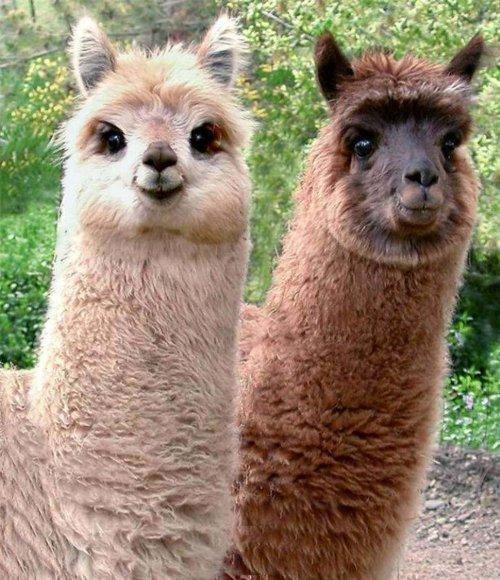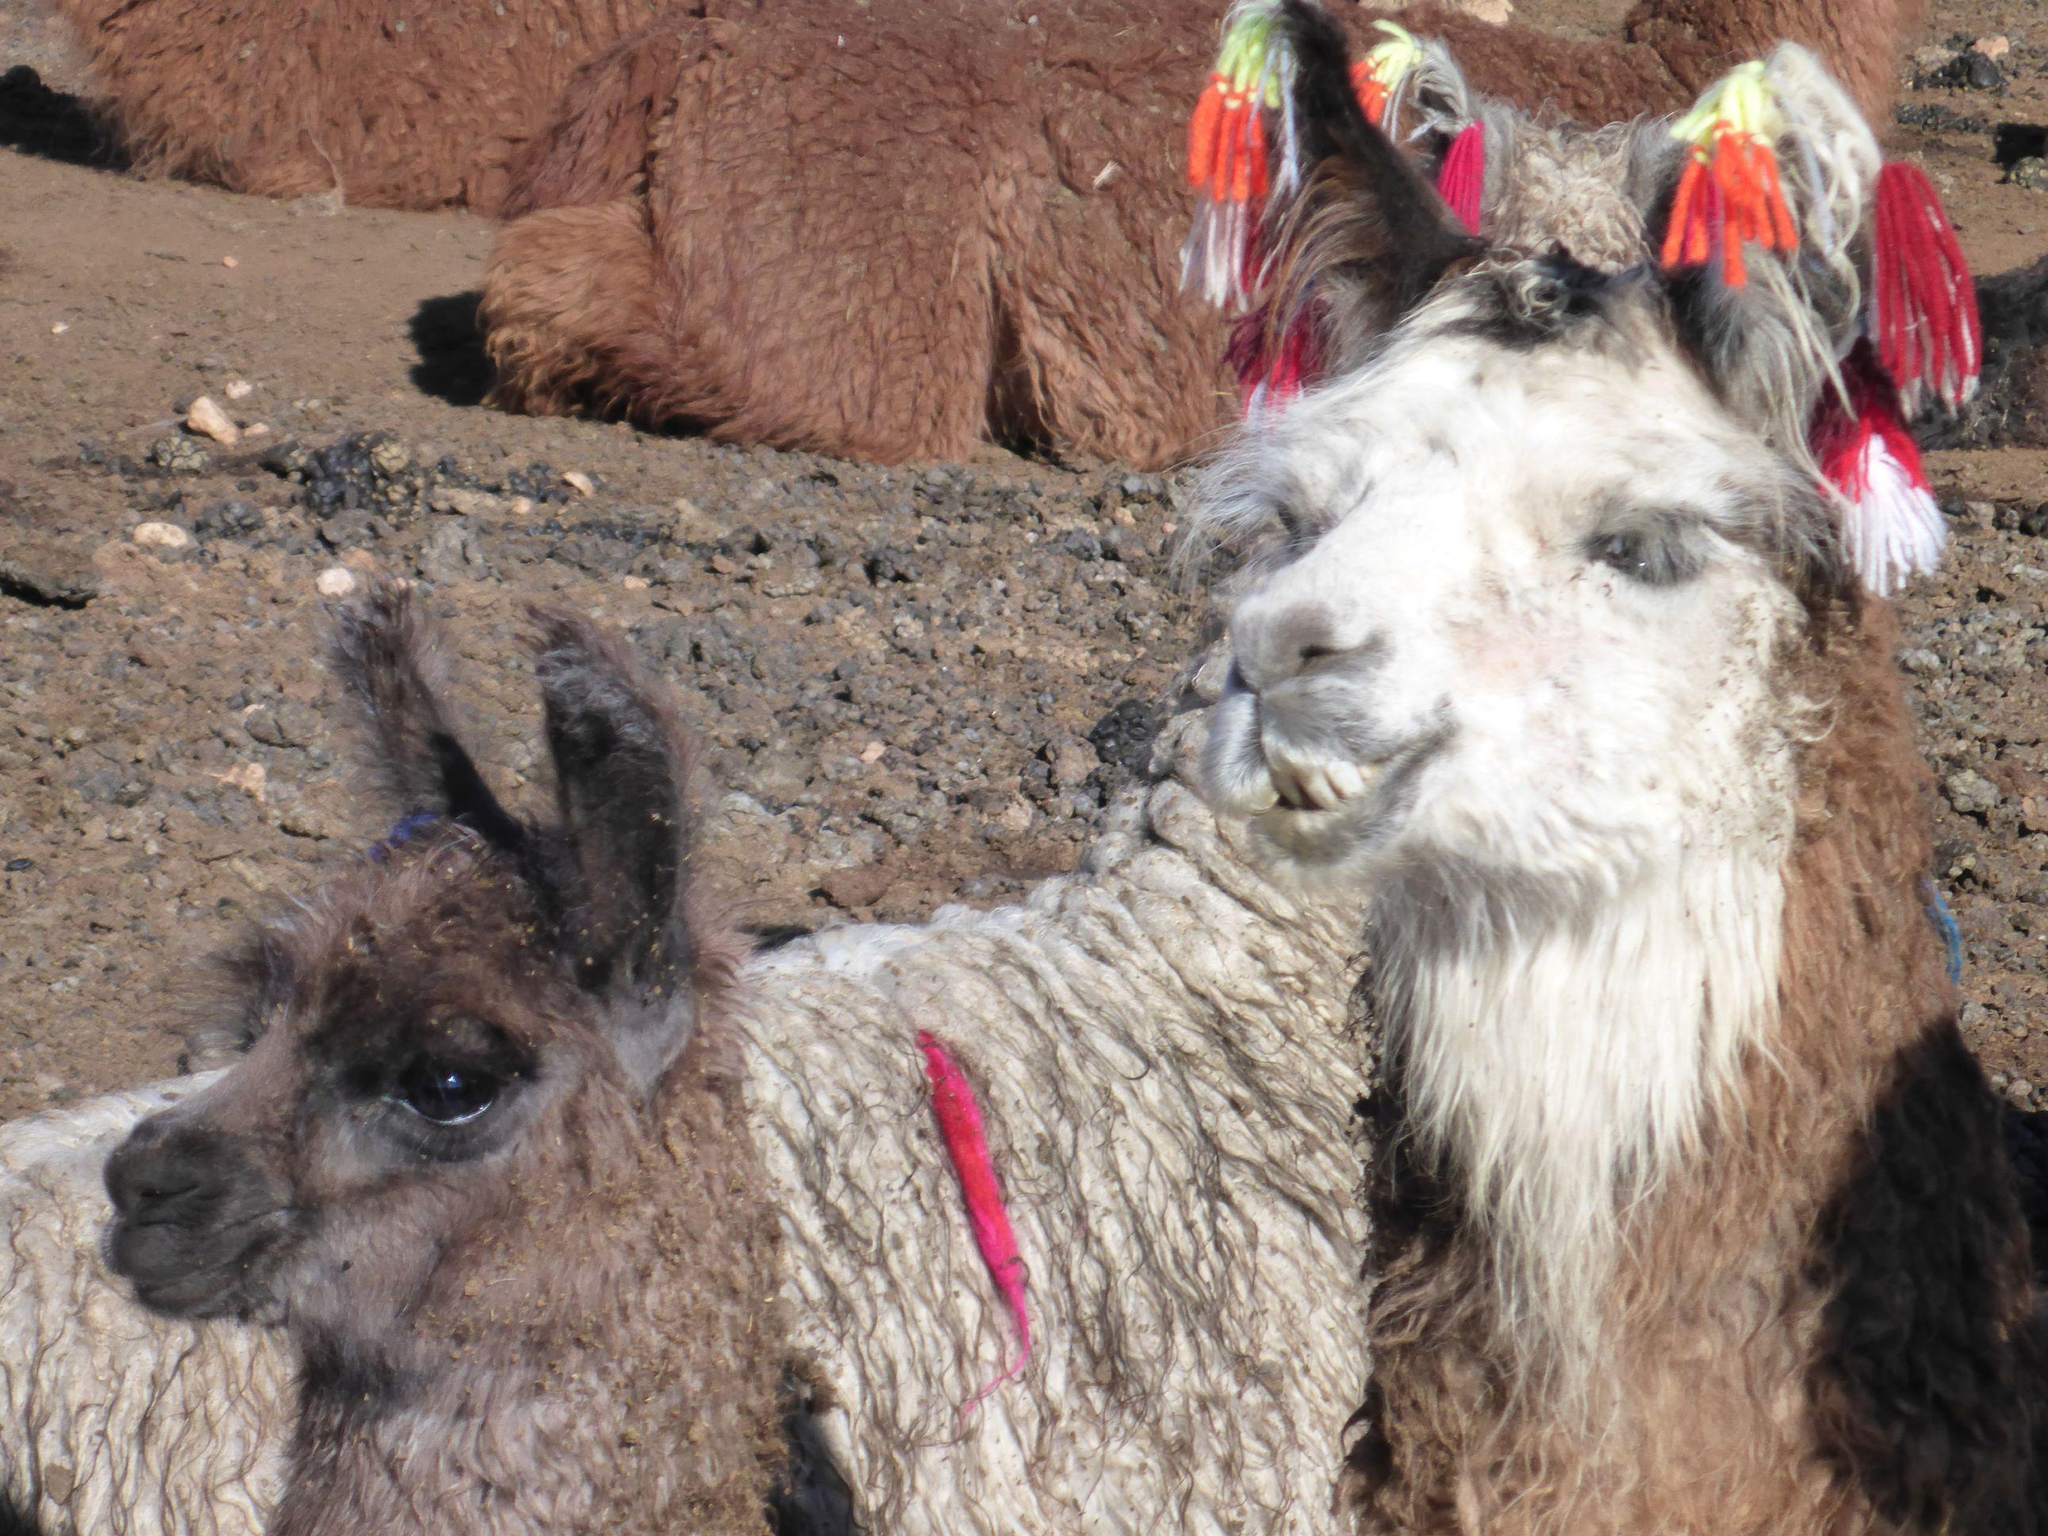The first image is the image on the left, the second image is the image on the right. For the images shown, is this caption "One of the images shows a llama with multicolored yarn decorations hanging from its ears." true? Answer yes or no. Yes. The first image is the image on the left, the second image is the image on the right. Evaluate the accuracy of this statement regarding the images: "At least one photo shows an animal with brightly colored tassels near its ears.". Is it true? Answer yes or no. Yes. 